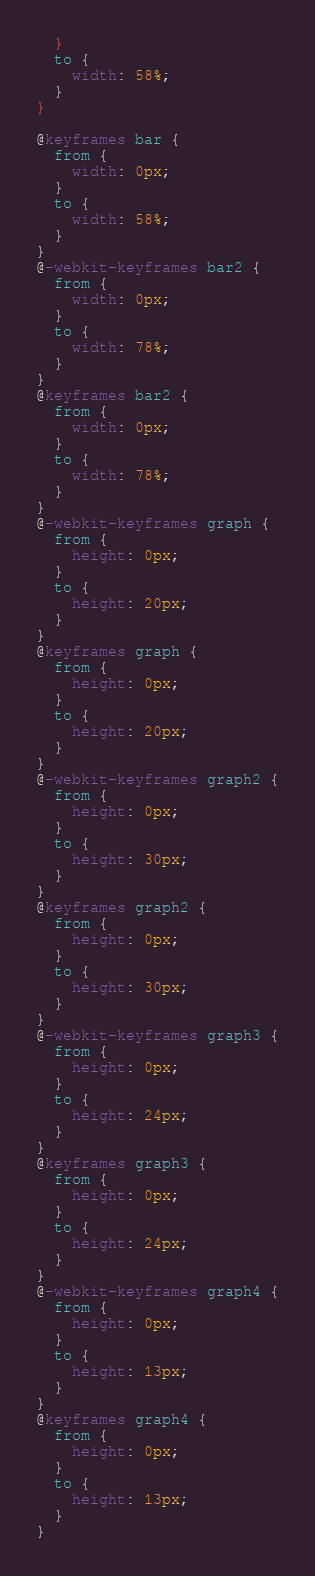<code> <loc_0><loc_0><loc_500><loc_500><_CSS_>  }
  to {
    width: 58%;
  }
}

@keyframes bar {
  from {
    width: 0px;
  }
  to {
    width: 58%;
  }
}
@-webkit-keyframes bar2 {
  from {
    width: 0px;
  }
  to {
    width: 78%;
  }
}
@keyframes bar2 {
  from {
    width: 0px;
  }
  to {
    width: 78%;
  }
}
@-webkit-keyframes graph {
  from {
    height: 0px;
  }
  to {
    height: 20px;
  }
}
@keyframes graph {
  from {
    height: 0px;
  }
  to {
    height: 20px;
  }
}
@-webkit-keyframes graph2 {
  from {
    height: 0px;
  }
  to {
    height: 30px;
  }
}
@keyframes graph2 {
  from {
    height: 0px;
  }
  to {
    height: 30px;
  }
}
@-webkit-keyframes graph3 {
  from {
    height: 0px;
  }
  to {
    height: 24px;
  }
}
@keyframes graph3 {
  from {
    height: 0px;
  }
  to {
    height: 24px;
  }
}
@-webkit-keyframes graph4 {
  from {
    height: 0px;
  }
  to {
    height: 13px;
  }
}
@keyframes graph4 {
  from {
    height: 0px;
  }
  to {
    height: 13px;
  }
}</code> 